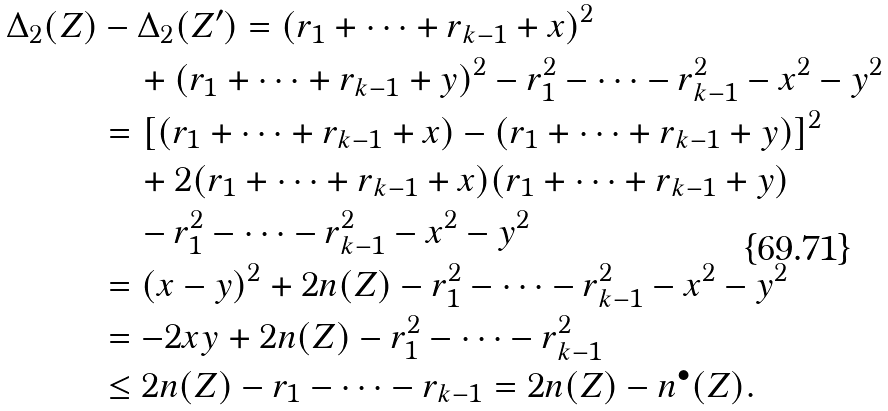Convert formula to latex. <formula><loc_0><loc_0><loc_500><loc_500>\Delta _ { 2 } ( Z ) & - \Delta _ { 2 } ( Z ^ { \prime } ) = ( r _ { 1 } + \dots + r _ { k - 1 } + x ) ^ { 2 } \\ & \quad + ( r _ { 1 } + \dots + r _ { k - 1 } + y ) ^ { 2 } - r _ { 1 } ^ { 2 } - \dots - r _ { k - 1 } ^ { 2 } - x ^ { 2 } - y ^ { 2 } \\ & = [ ( r _ { 1 } + \dots + r _ { k - 1 } + x ) - ( r _ { 1 } + \dots + r _ { k - 1 } + y ) ] ^ { 2 } \\ & \quad + 2 ( r _ { 1 } + \dots + r _ { k - 1 } + x ) ( r _ { 1 } + \dots + r _ { k - 1 } + y ) \\ & \quad - r _ { 1 } ^ { 2 } - \dots - r _ { k - 1 } ^ { 2 } - x ^ { 2 } - y ^ { 2 } \\ & = ( x - y ) ^ { 2 } + 2 n ( Z ) - r _ { 1 } ^ { 2 } - \dots - r _ { k - 1 } ^ { 2 } - x ^ { 2 } - y ^ { 2 } \\ & = - 2 x y + 2 n ( Z ) - r _ { 1 } ^ { 2 } - \dots - r _ { k - 1 } ^ { 2 } \\ & \leq 2 n ( Z ) - r _ { 1 } - \dots - r _ { k - 1 } = 2 n ( Z ) - n ^ { \bullet } ( Z ) .</formula> 